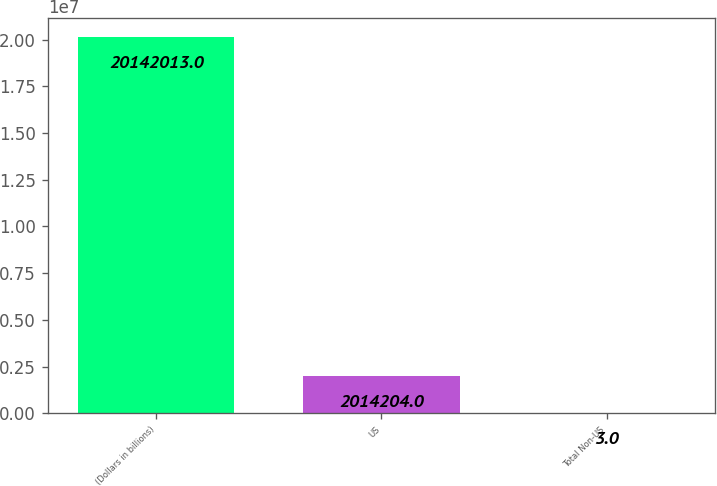Convert chart to OTSL. <chart><loc_0><loc_0><loc_500><loc_500><bar_chart><fcel>(Dollars in billions)<fcel>US<fcel>Total Non-US<nl><fcel>2.0142e+07<fcel>2.0142e+06<fcel>3<nl></chart> 